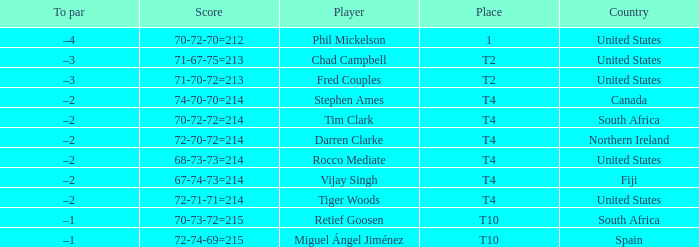What is Rocco Mediate's par? –2. 